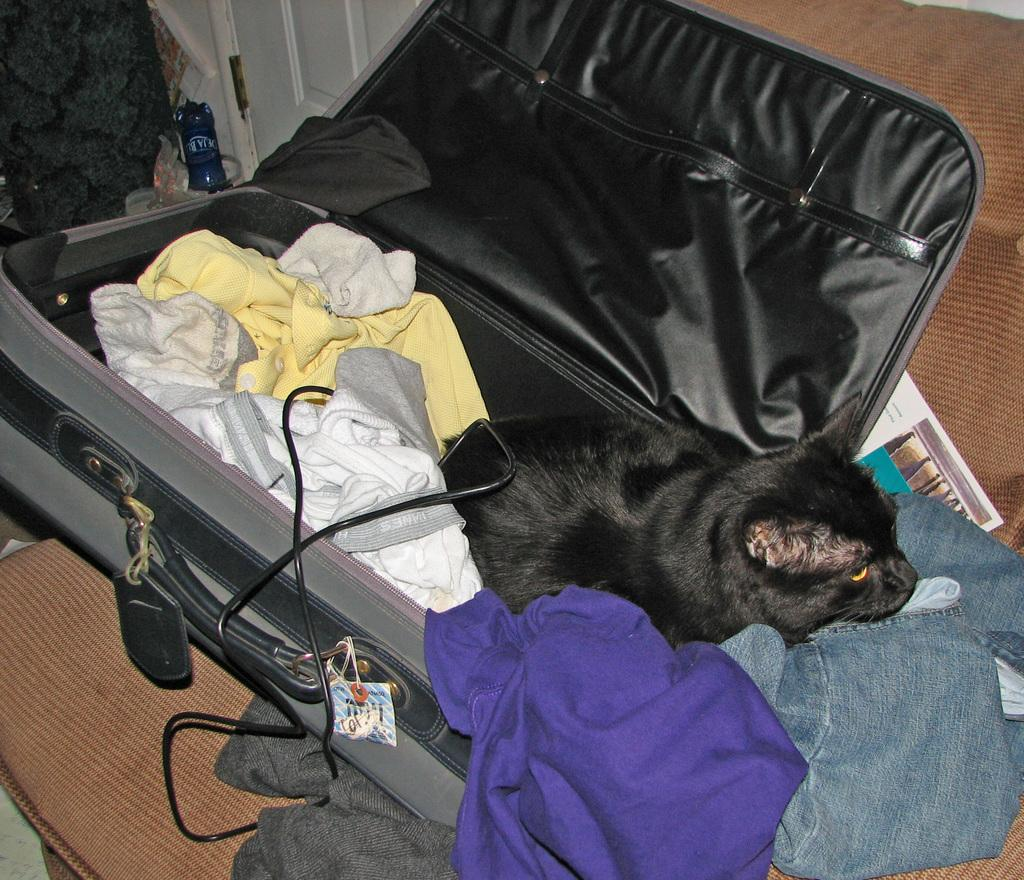What object is placed on the couch in the image? There is a suitcase on the couch in the image. What is inside the suitcase? The suitcase contains clothes. Is there any living creature inside the suitcase? Yes, there is a cat in the suitcase. What else can be found inside the suitcase besides clothes? There is a cable in the suitcase. Is there any additional information or message on the suitcase? Yes, there is a card on the backside of the suitcase. What type of mitten is the cat playing with in the suitcase? There is no mitten present in the image, and the cat is not shown playing with any object. 